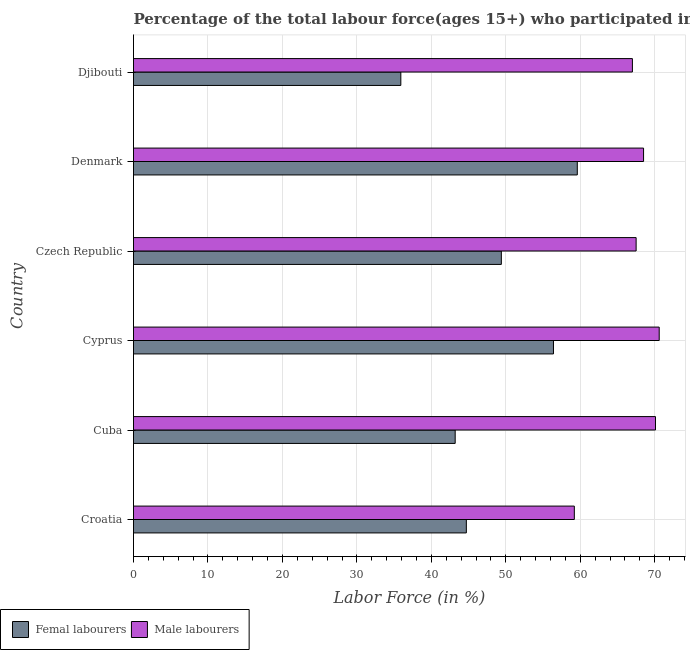How many different coloured bars are there?
Provide a short and direct response. 2. Are the number of bars per tick equal to the number of legend labels?
Provide a succinct answer. Yes. How many bars are there on the 4th tick from the bottom?
Your answer should be compact. 2. What is the label of the 5th group of bars from the top?
Your response must be concise. Cuba. In how many cases, is the number of bars for a given country not equal to the number of legend labels?
Your answer should be compact. 0. What is the percentage of male labour force in Denmark?
Ensure brevity in your answer.  68.5. Across all countries, what is the maximum percentage of female labor force?
Offer a terse response. 59.6. Across all countries, what is the minimum percentage of female labor force?
Keep it short and to the point. 35.9. In which country was the percentage of male labour force maximum?
Provide a succinct answer. Cyprus. In which country was the percentage of male labour force minimum?
Make the answer very short. Croatia. What is the total percentage of male labour force in the graph?
Your answer should be compact. 402.9. What is the difference between the percentage of female labor force in Cyprus and that in Denmark?
Offer a very short reply. -3.2. What is the difference between the percentage of female labor force in Croatia and the percentage of male labour force in Cyprus?
Provide a succinct answer. -25.9. What is the average percentage of male labour force per country?
Your answer should be compact. 67.15. What is the difference between the percentage of female labor force and percentage of male labour force in Cyprus?
Offer a terse response. -14.2. What is the ratio of the percentage of female labor force in Croatia to that in Djibouti?
Your answer should be very brief. 1.25. Is the sum of the percentage of male labour force in Croatia and Djibouti greater than the maximum percentage of female labor force across all countries?
Provide a succinct answer. Yes. What does the 1st bar from the top in Cyprus represents?
Provide a succinct answer. Male labourers. What does the 2nd bar from the bottom in Cyprus represents?
Ensure brevity in your answer.  Male labourers. How many bars are there?
Make the answer very short. 12. How many countries are there in the graph?
Your answer should be very brief. 6. What is the difference between two consecutive major ticks on the X-axis?
Make the answer very short. 10. Are the values on the major ticks of X-axis written in scientific E-notation?
Offer a very short reply. No. Does the graph contain grids?
Offer a terse response. Yes. Where does the legend appear in the graph?
Give a very brief answer. Bottom left. How many legend labels are there?
Your answer should be compact. 2. How are the legend labels stacked?
Your response must be concise. Horizontal. What is the title of the graph?
Offer a very short reply. Percentage of the total labour force(ages 15+) who participated in production in 2011. What is the label or title of the Y-axis?
Provide a succinct answer. Country. What is the Labor Force (in %) in Femal labourers in Croatia?
Provide a short and direct response. 44.7. What is the Labor Force (in %) of Male labourers in Croatia?
Offer a very short reply. 59.2. What is the Labor Force (in %) in Femal labourers in Cuba?
Your response must be concise. 43.2. What is the Labor Force (in %) of Male labourers in Cuba?
Your response must be concise. 70.1. What is the Labor Force (in %) in Femal labourers in Cyprus?
Offer a very short reply. 56.4. What is the Labor Force (in %) of Male labourers in Cyprus?
Give a very brief answer. 70.6. What is the Labor Force (in %) in Femal labourers in Czech Republic?
Provide a succinct answer. 49.4. What is the Labor Force (in %) in Male labourers in Czech Republic?
Offer a very short reply. 67.5. What is the Labor Force (in %) of Femal labourers in Denmark?
Make the answer very short. 59.6. What is the Labor Force (in %) in Male labourers in Denmark?
Offer a very short reply. 68.5. What is the Labor Force (in %) in Femal labourers in Djibouti?
Offer a very short reply. 35.9. What is the Labor Force (in %) in Male labourers in Djibouti?
Keep it short and to the point. 67. Across all countries, what is the maximum Labor Force (in %) of Femal labourers?
Provide a short and direct response. 59.6. Across all countries, what is the maximum Labor Force (in %) in Male labourers?
Offer a very short reply. 70.6. Across all countries, what is the minimum Labor Force (in %) in Femal labourers?
Give a very brief answer. 35.9. Across all countries, what is the minimum Labor Force (in %) in Male labourers?
Your answer should be very brief. 59.2. What is the total Labor Force (in %) of Femal labourers in the graph?
Ensure brevity in your answer.  289.2. What is the total Labor Force (in %) of Male labourers in the graph?
Your answer should be very brief. 402.9. What is the difference between the Labor Force (in %) of Femal labourers in Croatia and that in Cyprus?
Ensure brevity in your answer.  -11.7. What is the difference between the Labor Force (in %) in Male labourers in Croatia and that in Cyprus?
Ensure brevity in your answer.  -11.4. What is the difference between the Labor Force (in %) in Femal labourers in Croatia and that in Czech Republic?
Offer a very short reply. -4.7. What is the difference between the Labor Force (in %) of Femal labourers in Croatia and that in Denmark?
Your answer should be very brief. -14.9. What is the difference between the Labor Force (in %) in Femal labourers in Cuba and that in Cyprus?
Your answer should be compact. -13.2. What is the difference between the Labor Force (in %) in Male labourers in Cuba and that in Cyprus?
Make the answer very short. -0.5. What is the difference between the Labor Force (in %) of Femal labourers in Cuba and that in Denmark?
Offer a very short reply. -16.4. What is the difference between the Labor Force (in %) in Male labourers in Cuba and that in Denmark?
Offer a very short reply. 1.6. What is the difference between the Labor Force (in %) in Male labourers in Cuba and that in Djibouti?
Provide a succinct answer. 3.1. What is the difference between the Labor Force (in %) of Femal labourers in Cyprus and that in Denmark?
Provide a succinct answer. -3.2. What is the difference between the Labor Force (in %) of Femal labourers in Cyprus and that in Djibouti?
Offer a terse response. 20.5. What is the difference between the Labor Force (in %) in Male labourers in Cyprus and that in Djibouti?
Provide a succinct answer. 3.6. What is the difference between the Labor Force (in %) of Male labourers in Czech Republic and that in Denmark?
Offer a very short reply. -1. What is the difference between the Labor Force (in %) of Femal labourers in Czech Republic and that in Djibouti?
Offer a very short reply. 13.5. What is the difference between the Labor Force (in %) in Male labourers in Czech Republic and that in Djibouti?
Keep it short and to the point. 0.5. What is the difference between the Labor Force (in %) of Femal labourers in Denmark and that in Djibouti?
Keep it short and to the point. 23.7. What is the difference between the Labor Force (in %) of Femal labourers in Croatia and the Labor Force (in %) of Male labourers in Cuba?
Ensure brevity in your answer.  -25.4. What is the difference between the Labor Force (in %) of Femal labourers in Croatia and the Labor Force (in %) of Male labourers in Cyprus?
Provide a short and direct response. -25.9. What is the difference between the Labor Force (in %) in Femal labourers in Croatia and the Labor Force (in %) in Male labourers in Czech Republic?
Offer a terse response. -22.8. What is the difference between the Labor Force (in %) in Femal labourers in Croatia and the Labor Force (in %) in Male labourers in Denmark?
Your answer should be very brief. -23.8. What is the difference between the Labor Force (in %) in Femal labourers in Croatia and the Labor Force (in %) in Male labourers in Djibouti?
Give a very brief answer. -22.3. What is the difference between the Labor Force (in %) in Femal labourers in Cuba and the Labor Force (in %) in Male labourers in Cyprus?
Your response must be concise. -27.4. What is the difference between the Labor Force (in %) in Femal labourers in Cuba and the Labor Force (in %) in Male labourers in Czech Republic?
Ensure brevity in your answer.  -24.3. What is the difference between the Labor Force (in %) of Femal labourers in Cuba and the Labor Force (in %) of Male labourers in Denmark?
Your response must be concise. -25.3. What is the difference between the Labor Force (in %) in Femal labourers in Cuba and the Labor Force (in %) in Male labourers in Djibouti?
Offer a terse response. -23.8. What is the difference between the Labor Force (in %) in Femal labourers in Cyprus and the Labor Force (in %) in Male labourers in Denmark?
Your answer should be compact. -12.1. What is the difference between the Labor Force (in %) in Femal labourers in Czech Republic and the Labor Force (in %) in Male labourers in Denmark?
Ensure brevity in your answer.  -19.1. What is the difference between the Labor Force (in %) in Femal labourers in Czech Republic and the Labor Force (in %) in Male labourers in Djibouti?
Make the answer very short. -17.6. What is the average Labor Force (in %) in Femal labourers per country?
Your answer should be compact. 48.2. What is the average Labor Force (in %) in Male labourers per country?
Provide a short and direct response. 67.15. What is the difference between the Labor Force (in %) in Femal labourers and Labor Force (in %) in Male labourers in Croatia?
Your response must be concise. -14.5. What is the difference between the Labor Force (in %) in Femal labourers and Labor Force (in %) in Male labourers in Cuba?
Your answer should be compact. -26.9. What is the difference between the Labor Force (in %) of Femal labourers and Labor Force (in %) of Male labourers in Cyprus?
Make the answer very short. -14.2. What is the difference between the Labor Force (in %) of Femal labourers and Labor Force (in %) of Male labourers in Czech Republic?
Your answer should be very brief. -18.1. What is the difference between the Labor Force (in %) of Femal labourers and Labor Force (in %) of Male labourers in Djibouti?
Give a very brief answer. -31.1. What is the ratio of the Labor Force (in %) in Femal labourers in Croatia to that in Cuba?
Provide a short and direct response. 1.03. What is the ratio of the Labor Force (in %) in Male labourers in Croatia to that in Cuba?
Your answer should be very brief. 0.84. What is the ratio of the Labor Force (in %) in Femal labourers in Croatia to that in Cyprus?
Your answer should be compact. 0.79. What is the ratio of the Labor Force (in %) of Male labourers in Croatia to that in Cyprus?
Provide a short and direct response. 0.84. What is the ratio of the Labor Force (in %) in Femal labourers in Croatia to that in Czech Republic?
Offer a terse response. 0.9. What is the ratio of the Labor Force (in %) in Male labourers in Croatia to that in Czech Republic?
Your response must be concise. 0.88. What is the ratio of the Labor Force (in %) in Femal labourers in Croatia to that in Denmark?
Offer a terse response. 0.75. What is the ratio of the Labor Force (in %) of Male labourers in Croatia to that in Denmark?
Make the answer very short. 0.86. What is the ratio of the Labor Force (in %) of Femal labourers in Croatia to that in Djibouti?
Ensure brevity in your answer.  1.25. What is the ratio of the Labor Force (in %) of Male labourers in Croatia to that in Djibouti?
Give a very brief answer. 0.88. What is the ratio of the Labor Force (in %) of Femal labourers in Cuba to that in Cyprus?
Give a very brief answer. 0.77. What is the ratio of the Labor Force (in %) of Male labourers in Cuba to that in Cyprus?
Offer a terse response. 0.99. What is the ratio of the Labor Force (in %) in Femal labourers in Cuba to that in Czech Republic?
Your answer should be very brief. 0.87. What is the ratio of the Labor Force (in %) of Femal labourers in Cuba to that in Denmark?
Your response must be concise. 0.72. What is the ratio of the Labor Force (in %) of Male labourers in Cuba to that in Denmark?
Offer a very short reply. 1.02. What is the ratio of the Labor Force (in %) of Femal labourers in Cuba to that in Djibouti?
Ensure brevity in your answer.  1.2. What is the ratio of the Labor Force (in %) of Male labourers in Cuba to that in Djibouti?
Offer a very short reply. 1.05. What is the ratio of the Labor Force (in %) of Femal labourers in Cyprus to that in Czech Republic?
Keep it short and to the point. 1.14. What is the ratio of the Labor Force (in %) in Male labourers in Cyprus to that in Czech Republic?
Your answer should be compact. 1.05. What is the ratio of the Labor Force (in %) in Femal labourers in Cyprus to that in Denmark?
Your response must be concise. 0.95. What is the ratio of the Labor Force (in %) in Male labourers in Cyprus to that in Denmark?
Give a very brief answer. 1.03. What is the ratio of the Labor Force (in %) in Femal labourers in Cyprus to that in Djibouti?
Make the answer very short. 1.57. What is the ratio of the Labor Force (in %) in Male labourers in Cyprus to that in Djibouti?
Your answer should be compact. 1.05. What is the ratio of the Labor Force (in %) in Femal labourers in Czech Republic to that in Denmark?
Your answer should be very brief. 0.83. What is the ratio of the Labor Force (in %) in Male labourers in Czech Republic to that in Denmark?
Ensure brevity in your answer.  0.99. What is the ratio of the Labor Force (in %) of Femal labourers in Czech Republic to that in Djibouti?
Keep it short and to the point. 1.38. What is the ratio of the Labor Force (in %) in Male labourers in Czech Republic to that in Djibouti?
Ensure brevity in your answer.  1.01. What is the ratio of the Labor Force (in %) in Femal labourers in Denmark to that in Djibouti?
Provide a succinct answer. 1.66. What is the ratio of the Labor Force (in %) in Male labourers in Denmark to that in Djibouti?
Offer a terse response. 1.02. What is the difference between the highest and the second highest Labor Force (in %) of Femal labourers?
Your answer should be very brief. 3.2. What is the difference between the highest and the second highest Labor Force (in %) of Male labourers?
Your answer should be very brief. 0.5. What is the difference between the highest and the lowest Labor Force (in %) in Femal labourers?
Keep it short and to the point. 23.7. What is the difference between the highest and the lowest Labor Force (in %) of Male labourers?
Your response must be concise. 11.4. 